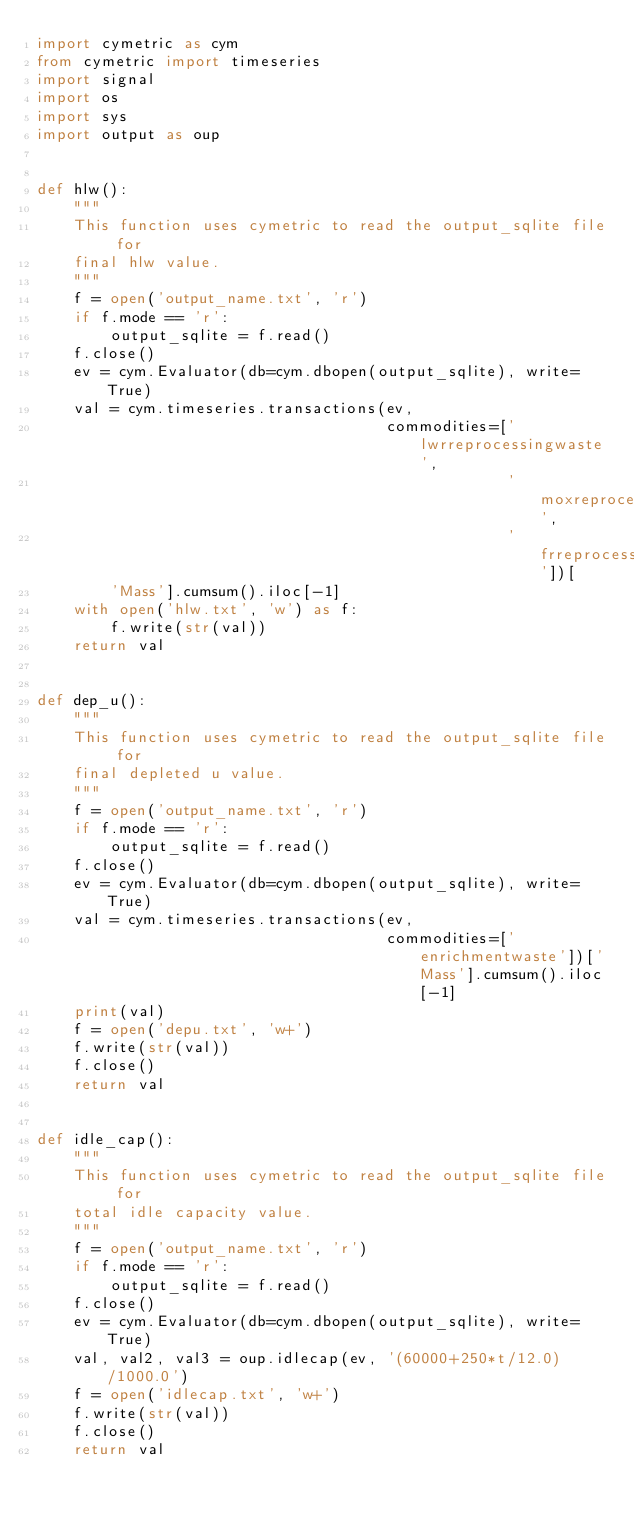Convert code to text. <code><loc_0><loc_0><loc_500><loc_500><_Python_>import cymetric as cym
from cymetric import timeseries
import signal
import os
import sys
import output as oup


def hlw():
    """
    This function uses cymetric to read the output_sqlite file for 
    final hlw value. 
    """
    f = open('output_name.txt', 'r')
    if f.mode == 'r':
        output_sqlite = f.read()
    f.close()
    ev = cym.Evaluator(db=cym.dbopen(output_sqlite), write=True)
    val = cym.timeseries.transactions(ev,
                                      commodities=['lwrreprocessingwaste',
                                                   'moxreprocessingwaste',
                                                   'frreprocessingwaste'])[
        'Mass'].cumsum().iloc[-1]
    with open('hlw.txt', 'w') as f:
        f.write(str(val))
    return val


def dep_u():
    """
    This function uses cymetric to read the output_sqlite file for 
    final depleted u value. 
    """
    f = open('output_name.txt', 'r')
    if f.mode == 'r':
        output_sqlite = f.read()
    f.close()
    ev = cym.Evaluator(db=cym.dbopen(output_sqlite), write=True)
    val = cym.timeseries.transactions(ev,
                                      commodities=['enrichmentwaste'])['Mass'].cumsum().iloc[-1]
    print(val)
    f = open('depu.txt', 'w+')
    f.write(str(val))
    f.close()
    return val


def idle_cap():
    """
    This function uses cymetric to read the output_sqlite file for 
    total idle capacity value. 
    """
    f = open('output_name.txt', 'r')
    if f.mode == 'r':
        output_sqlite = f.read()
    f.close()
    ev = cym.Evaluator(db=cym.dbopen(output_sqlite), write=True)
    val, val2, val3 = oup.idlecap(ev, '(60000+250*t/12.0)/1000.0')
    f = open('idlecap.txt', 'w+')
    f.write(str(val))
    f.close()
    return val
</code> 